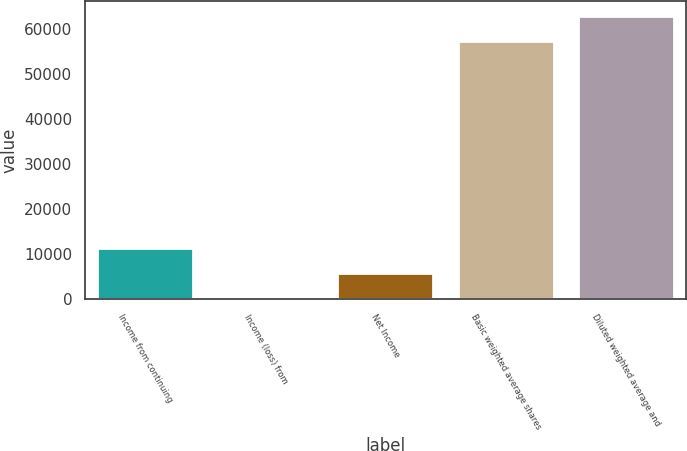<chart> <loc_0><loc_0><loc_500><loc_500><bar_chart><fcel>Income from continuing<fcel>Income (loss) from<fcel>Net Income<fcel>Basic weighted average shares<fcel>Diluted weighted average and<nl><fcel>11485.6<fcel>0.05<fcel>5742.85<fcel>57143<fcel>62885.8<nl></chart> 